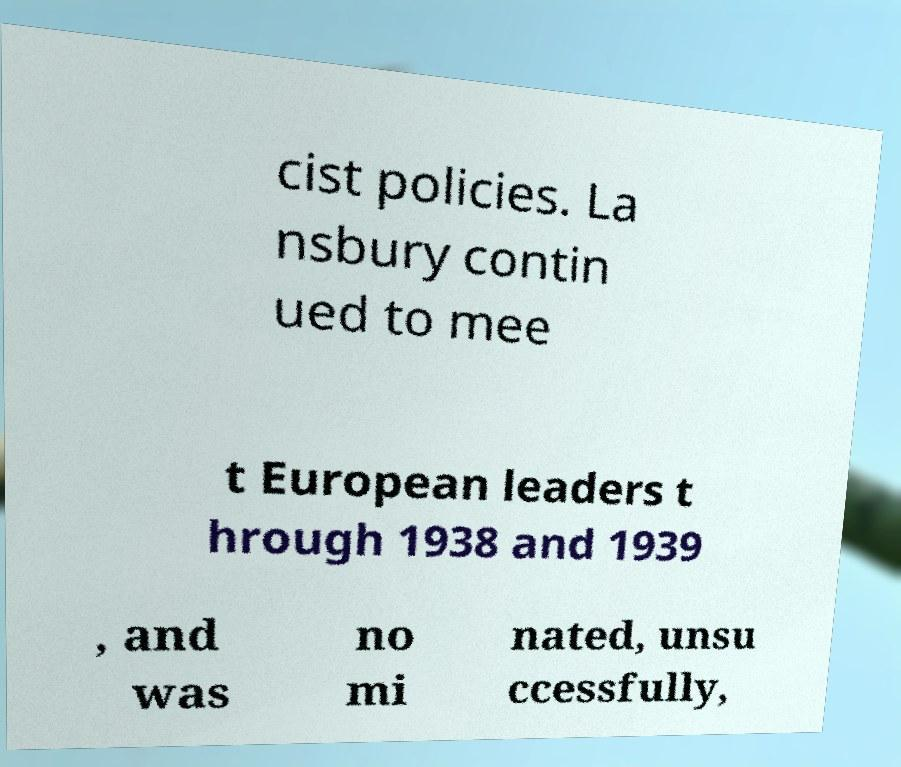There's text embedded in this image that I need extracted. Can you transcribe it verbatim? cist policies. La nsbury contin ued to mee t European leaders t hrough 1938 and 1939 , and was no mi nated, unsu ccessfully, 